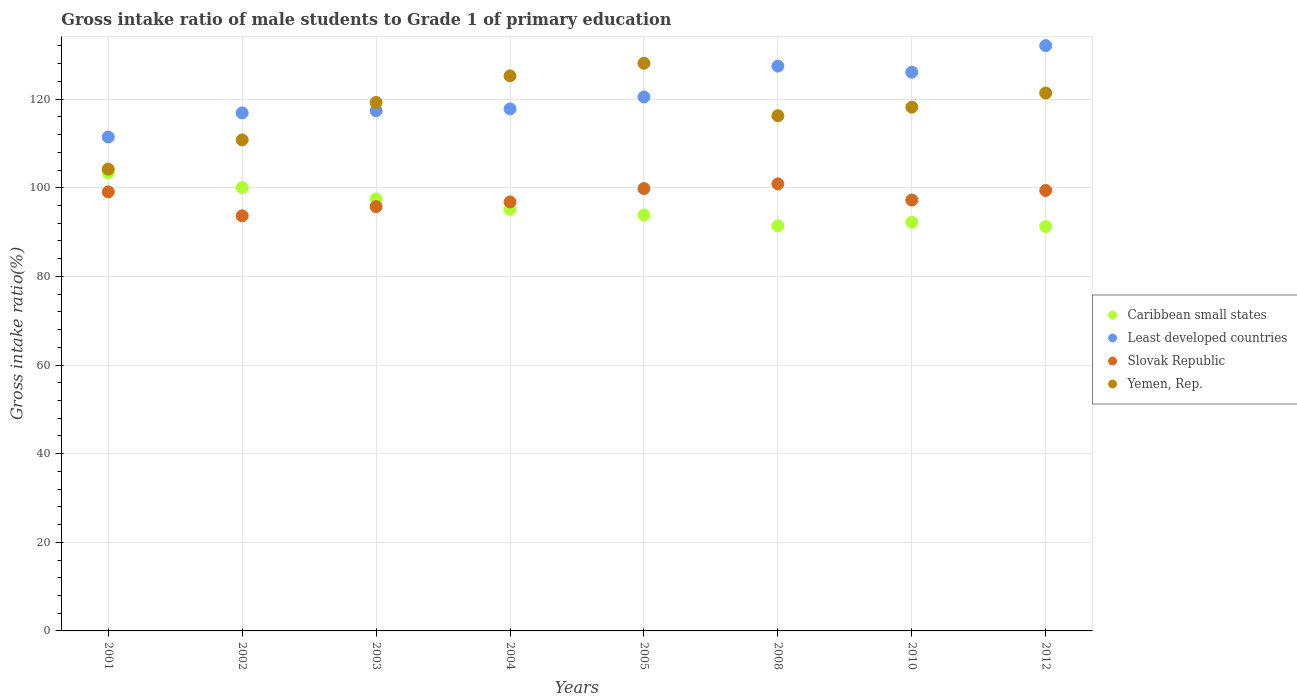What is the gross intake ratio in Caribbean small states in 2005?
Your answer should be very brief. 93.86. Across all years, what is the maximum gross intake ratio in Yemen, Rep.?
Make the answer very short. 128.1. Across all years, what is the minimum gross intake ratio in Yemen, Rep.?
Offer a terse response. 104.21. What is the total gross intake ratio in Least developed countries in the graph?
Your response must be concise. 969.67. What is the difference between the gross intake ratio in Least developed countries in 2001 and that in 2002?
Offer a terse response. -5.45. What is the difference between the gross intake ratio in Least developed countries in 2002 and the gross intake ratio in Caribbean small states in 2012?
Offer a terse response. 25.65. What is the average gross intake ratio in Least developed countries per year?
Offer a terse response. 121.21. In the year 2008, what is the difference between the gross intake ratio in Caribbean small states and gross intake ratio in Yemen, Rep.?
Keep it short and to the point. -24.82. In how many years, is the gross intake ratio in Least developed countries greater than 76 %?
Offer a very short reply. 8. What is the ratio of the gross intake ratio in Caribbean small states in 2002 to that in 2008?
Provide a short and direct response. 1.09. What is the difference between the highest and the second highest gross intake ratio in Yemen, Rep.?
Ensure brevity in your answer.  2.84. What is the difference between the highest and the lowest gross intake ratio in Slovak Republic?
Your response must be concise. 7.21. Is it the case that in every year, the sum of the gross intake ratio in Caribbean small states and gross intake ratio in Slovak Republic  is greater than the sum of gross intake ratio in Yemen, Rep. and gross intake ratio in Least developed countries?
Provide a short and direct response. No. Is it the case that in every year, the sum of the gross intake ratio in Least developed countries and gross intake ratio in Caribbean small states  is greater than the gross intake ratio in Yemen, Rep.?
Make the answer very short. Yes. Does the gross intake ratio in Caribbean small states monotonically increase over the years?
Your answer should be very brief. No. Are the values on the major ticks of Y-axis written in scientific E-notation?
Provide a succinct answer. No. Does the graph contain any zero values?
Provide a succinct answer. No. Where does the legend appear in the graph?
Offer a very short reply. Center right. How are the legend labels stacked?
Your answer should be very brief. Vertical. What is the title of the graph?
Offer a very short reply. Gross intake ratio of male students to Grade 1 of primary education. What is the label or title of the Y-axis?
Keep it short and to the point. Gross intake ratio(%). What is the Gross intake ratio(%) of Caribbean small states in 2001?
Keep it short and to the point. 103.36. What is the Gross intake ratio(%) of Least developed countries in 2001?
Provide a succinct answer. 111.45. What is the Gross intake ratio(%) in Slovak Republic in 2001?
Keep it short and to the point. 99.08. What is the Gross intake ratio(%) of Yemen, Rep. in 2001?
Provide a short and direct response. 104.21. What is the Gross intake ratio(%) in Caribbean small states in 2002?
Provide a short and direct response. 100.05. What is the Gross intake ratio(%) in Least developed countries in 2002?
Make the answer very short. 116.91. What is the Gross intake ratio(%) in Slovak Republic in 2002?
Your response must be concise. 93.67. What is the Gross intake ratio(%) of Yemen, Rep. in 2002?
Offer a terse response. 110.8. What is the Gross intake ratio(%) in Caribbean small states in 2003?
Provide a short and direct response. 97.49. What is the Gross intake ratio(%) of Least developed countries in 2003?
Provide a succinct answer. 117.39. What is the Gross intake ratio(%) of Slovak Republic in 2003?
Your answer should be compact. 95.75. What is the Gross intake ratio(%) in Yemen, Rep. in 2003?
Make the answer very short. 119.26. What is the Gross intake ratio(%) of Caribbean small states in 2004?
Ensure brevity in your answer.  95.14. What is the Gross intake ratio(%) in Least developed countries in 2004?
Your response must be concise. 117.81. What is the Gross intake ratio(%) in Slovak Republic in 2004?
Ensure brevity in your answer.  96.81. What is the Gross intake ratio(%) in Yemen, Rep. in 2004?
Give a very brief answer. 125.26. What is the Gross intake ratio(%) in Caribbean small states in 2005?
Offer a very short reply. 93.86. What is the Gross intake ratio(%) of Least developed countries in 2005?
Your answer should be compact. 120.49. What is the Gross intake ratio(%) of Slovak Republic in 2005?
Your answer should be very brief. 99.82. What is the Gross intake ratio(%) of Yemen, Rep. in 2005?
Make the answer very short. 128.1. What is the Gross intake ratio(%) in Caribbean small states in 2008?
Make the answer very short. 91.44. What is the Gross intake ratio(%) in Least developed countries in 2008?
Your answer should be very brief. 127.46. What is the Gross intake ratio(%) in Slovak Republic in 2008?
Keep it short and to the point. 100.88. What is the Gross intake ratio(%) of Yemen, Rep. in 2008?
Ensure brevity in your answer.  116.26. What is the Gross intake ratio(%) of Caribbean small states in 2010?
Keep it short and to the point. 92.23. What is the Gross intake ratio(%) in Least developed countries in 2010?
Provide a succinct answer. 126.09. What is the Gross intake ratio(%) of Slovak Republic in 2010?
Offer a very short reply. 97.24. What is the Gross intake ratio(%) in Yemen, Rep. in 2010?
Offer a very short reply. 118.19. What is the Gross intake ratio(%) of Caribbean small states in 2012?
Give a very brief answer. 91.25. What is the Gross intake ratio(%) of Least developed countries in 2012?
Make the answer very short. 132.08. What is the Gross intake ratio(%) of Slovak Republic in 2012?
Your answer should be very brief. 99.39. What is the Gross intake ratio(%) of Yemen, Rep. in 2012?
Your answer should be very brief. 121.39. Across all years, what is the maximum Gross intake ratio(%) in Caribbean small states?
Offer a terse response. 103.36. Across all years, what is the maximum Gross intake ratio(%) in Least developed countries?
Your response must be concise. 132.08. Across all years, what is the maximum Gross intake ratio(%) in Slovak Republic?
Your answer should be compact. 100.88. Across all years, what is the maximum Gross intake ratio(%) in Yemen, Rep.?
Keep it short and to the point. 128.1. Across all years, what is the minimum Gross intake ratio(%) of Caribbean small states?
Offer a very short reply. 91.25. Across all years, what is the minimum Gross intake ratio(%) in Least developed countries?
Provide a short and direct response. 111.45. Across all years, what is the minimum Gross intake ratio(%) of Slovak Republic?
Your answer should be very brief. 93.67. Across all years, what is the minimum Gross intake ratio(%) in Yemen, Rep.?
Offer a very short reply. 104.21. What is the total Gross intake ratio(%) in Caribbean small states in the graph?
Provide a short and direct response. 764.82. What is the total Gross intake ratio(%) of Least developed countries in the graph?
Your answer should be compact. 969.67. What is the total Gross intake ratio(%) of Slovak Republic in the graph?
Keep it short and to the point. 782.64. What is the total Gross intake ratio(%) of Yemen, Rep. in the graph?
Offer a terse response. 943.48. What is the difference between the Gross intake ratio(%) in Caribbean small states in 2001 and that in 2002?
Provide a short and direct response. 3.31. What is the difference between the Gross intake ratio(%) in Least developed countries in 2001 and that in 2002?
Your answer should be very brief. -5.45. What is the difference between the Gross intake ratio(%) in Slovak Republic in 2001 and that in 2002?
Offer a very short reply. 5.41. What is the difference between the Gross intake ratio(%) of Yemen, Rep. in 2001 and that in 2002?
Provide a succinct answer. -6.59. What is the difference between the Gross intake ratio(%) in Caribbean small states in 2001 and that in 2003?
Your answer should be compact. 5.87. What is the difference between the Gross intake ratio(%) of Least developed countries in 2001 and that in 2003?
Offer a very short reply. -5.93. What is the difference between the Gross intake ratio(%) of Slovak Republic in 2001 and that in 2003?
Make the answer very short. 3.32. What is the difference between the Gross intake ratio(%) of Yemen, Rep. in 2001 and that in 2003?
Your answer should be compact. -15.05. What is the difference between the Gross intake ratio(%) of Caribbean small states in 2001 and that in 2004?
Your answer should be compact. 8.22. What is the difference between the Gross intake ratio(%) in Least developed countries in 2001 and that in 2004?
Keep it short and to the point. -6.35. What is the difference between the Gross intake ratio(%) in Slovak Republic in 2001 and that in 2004?
Keep it short and to the point. 2.27. What is the difference between the Gross intake ratio(%) in Yemen, Rep. in 2001 and that in 2004?
Offer a terse response. -21.05. What is the difference between the Gross intake ratio(%) in Caribbean small states in 2001 and that in 2005?
Your response must be concise. 9.5. What is the difference between the Gross intake ratio(%) in Least developed countries in 2001 and that in 2005?
Offer a very short reply. -9.04. What is the difference between the Gross intake ratio(%) in Slovak Republic in 2001 and that in 2005?
Ensure brevity in your answer.  -0.75. What is the difference between the Gross intake ratio(%) of Yemen, Rep. in 2001 and that in 2005?
Ensure brevity in your answer.  -23.89. What is the difference between the Gross intake ratio(%) of Caribbean small states in 2001 and that in 2008?
Give a very brief answer. 11.92. What is the difference between the Gross intake ratio(%) in Least developed countries in 2001 and that in 2008?
Offer a very short reply. -16.01. What is the difference between the Gross intake ratio(%) in Slovak Republic in 2001 and that in 2008?
Your answer should be compact. -1.8. What is the difference between the Gross intake ratio(%) of Yemen, Rep. in 2001 and that in 2008?
Make the answer very short. -12.05. What is the difference between the Gross intake ratio(%) of Caribbean small states in 2001 and that in 2010?
Offer a terse response. 11.13. What is the difference between the Gross intake ratio(%) in Least developed countries in 2001 and that in 2010?
Ensure brevity in your answer.  -14.63. What is the difference between the Gross intake ratio(%) in Slovak Republic in 2001 and that in 2010?
Your answer should be compact. 1.84. What is the difference between the Gross intake ratio(%) in Yemen, Rep. in 2001 and that in 2010?
Your answer should be compact. -13.98. What is the difference between the Gross intake ratio(%) of Caribbean small states in 2001 and that in 2012?
Your answer should be compact. 12.11. What is the difference between the Gross intake ratio(%) of Least developed countries in 2001 and that in 2012?
Give a very brief answer. -20.63. What is the difference between the Gross intake ratio(%) of Slovak Republic in 2001 and that in 2012?
Your answer should be very brief. -0.32. What is the difference between the Gross intake ratio(%) in Yemen, Rep. in 2001 and that in 2012?
Make the answer very short. -17.18. What is the difference between the Gross intake ratio(%) in Caribbean small states in 2002 and that in 2003?
Provide a succinct answer. 2.56. What is the difference between the Gross intake ratio(%) in Least developed countries in 2002 and that in 2003?
Make the answer very short. -0.48. What is the difference between the Gross intake ratio(%) in Slovak Republic in 2002 and that in 2003?
Make the answer very short. -2.08. What is the difference between the Gross intake ratio(%) of Yemen, Rep. in 2002 and that in 2003?
Give a very brief answer. -8.46. What is the difference between the Gross intake ratio(%) in Caribbean small states in 2002 and that in 2004?
Provide a succinct answer. 4.91. What is the difference between the Gross intake ratio(%) of Least developed countries in 2002 and that in 2004?
Offer a terse response. -0.9. What is the difference between the Gross intake ratio(%) of Slovak Republic in 2002 and that in 2004?
Keep it short and to the point. -3.14. What is the difference between the Gross intake ratio(%) in Yemen, Rep. in 2002 and that in 2004?
Your response must be concise. -14.46. What is the difference between the Gross intake ratio(%) of Caribbean small states in 2002 and that in 2005?
Ensure brevity in your answer.  6.19. What is the difference between the Gross intake ratio(%) in Least developed countries in 2002 and that in 2005?
Offer a very short reply. -3.58. What is the difference between the Gross intake ratio(%) of Slovak Republic in 2002 and that in 2005?
Offer a very short reply. -6.15. What is the difference between the Gross intake ratio(%) in Yemen, Rep. in 2002 and that in 2005?
Provide a short and direct response. -17.3. What is the difference between the Gross intake ratio(%) in Caribbean small states in 2002 and that in 2008?
Your answer should be very brief. 8.61. What is the difference between the Gross intake ratio(%) of Least developed countries in 2002 and that in 2008?
Offer a very short reply. -10.55. What is the difference between the Gross intake ratio(%) in Slovak Republic in 2002 and that in 2008?
Offer a terse response. -7.21. What is the difference between the Gross intake ratio(%) in Yemen, Rep. in 2002 and that in 2008?
Offer a very short reply. -5.46. What is the difference between the Gross intake ratio(%) of Caribbean small states in 2002 and that in 2010?
Make the answer very short. 7.82. What is the difference between the Gross intake ratio(%) in Least developed countries in 2002 and that in 2010?
Your answer should be compact. -9.18. What is the difference between the Gross intake ratio(%) in Slovak Republic in 2002 and that in 2010?
Make the answer very short. -3.57. What is the difference between the Gross intake ratio(%) of Yemen, Rep. in 2002 and that in 2010?
Your response must be concise. -7.39. What is the difference between the Gross intake ratio(%) in Caribbean small states in 2002 and that in 2012?
Ensure brevity in your answer.  8.8. What is the difference between the Gross intake ratio(%) of Least developed countries in 2002 and that in 2012?
Your answer should be compact. -15.18. What is the difference between the Gross intake ratio(%) in Slovak Republic in 2002 and that in 2012?
Your response must be concise. -5.72. What is the difference between the Gross intake ratio(%) in Yemen, Rep. in 2002 and that in 2012?
Offer a terse response. -10.59. What is the difference between the Gross intake ratio(%) in Caribbean small states in 2003 and that in 2004?
Keep it short and to the point. 2.35. What is the difference between the Gross intake ratio(%) in Least developed countries in 2003 and that in 2004?
Your response must be concise. -0.42. What is the difference between the Gross intake ratio(%) in Slovak Republic in 2003 and that in 2004?
Offer a very short reply. -1.06. What is the difference between the Gross intake ratio(%) of Yemen, Rep. in 2003 and that in 2004?
Your answer should be very brief. -6. What is the difference between the Gross intake ratio(%) of Caribbean small states in 2003 and that in 2005?
Ensure brevity in your answer.  3.62. What is the difference between the Gross intake ratio(%) in Least developed countries in 2003 and that in 2005?
Offer a terse response. -3.1. What is the difference between the Gross intake ratio(%) of Slovak Republic in 2003 and that in 2005?
Provide a succinct answer. -4.07. What is the difference between the Gross intake ratio(%) of Yemen, Rep. in 2003 and that in 2005?
Make the answer very short. -8.84. What is the difference between the Gross intake ratio(%) in Caribbean small states in 2003 and that in 2008?
Give a very brief answer. 6.05. What is the difference between the Gross intake ratio(%) in Least developed countries in 2003 and that in 2008?
Keep it short and to the point. -10.07. What is the difference between the Gross intake ratio(%) of Slovak Republic in 2003 and that in 2008?
Offer a terse response. -5.13. What is the difference between the Gross intake ratio(%) of Yemen, Rep. in 2003 and that in 2008?
Provide a succinct answer. 3. What is the difference between the Gross intake ratio(%) of Caribbean small states in 2003 and that in 2010?
Your answer should be very brief. 5.26. What is the difference between the Gross intake ratio(%) of Least developed countries in 2003 and that in 2010?
Your response must be concise. -8.7. What is the difference between the Gross intake ratio(%) of Slovak Republic in 2003 and that in 2010?
Give a very brief answer. -1.48. What is the difference between the Gross intake ratio(%) of Yemen, Rep. in 2003 and that in 2010?
Provide a short and direct response. 1.06. What is the difference between the Gross intake ratio(%) in Caribbean small states in 2003 and that in 2012?
Provide a succinct answer. 6.24. What is the difference between the Gross intake ratio(%) of Least developed countries in 2003 and that in 2012?
Ensure brevity in your answer.  -14.7. What is the difference between the Gross intake ratio(%) of Slovak Republic in 2003 and that in 2012?
Offer a terse response. -3.64. What is the difference between the Gross intake ratio(%) of Yemen, Rep. in 2003 and that in 2012?
Ensure brevity in your answer.  -2.14. What is the difference between the Gross intake ratio(%) of Caribbean small states in 2004 and that in 2005?
Ensure brevity in your answer.  1.27. What is the difference between the Gross intake ratio(%) of Least developed countries in 2004 and that in 2005?
Your answer should be very brief. -2.68. What is the difference between the Gross intake ratio(%) of Slovak Republic in 2004 and that in 2005?
Offer a terse response. -3.01. What is the difference between the Gross intake ratio(%) in Yemen, Rep. in 2004 and that in 2005?
Provide a short and direct response. -2.84. What is the difference between the Gross intake ratio(%) of Caribbean small states in 2004 and that in 2008?
Your answer should be very brief. 3.7. What is the difference between the Gross intake ratio(%) of Least developed countries in 2004 and that in 2008?
Your answer should be very brief. -9.65. What is the difference between the Gross intake ratio(%) in Slovak Republic in 2004 and that in 2008?
Give a very brief answer. -4.07. What is the difference between the Gross intake ratio(%) in Yemen, Rep. in 2004 and that in 2008?
Your answer should be compact. 9. What is the difference between the Gross intake ratio(%) of Caribbean small states in 2004 and that in 2010?
Your response must be concise. 2.91. What is the difference between the Gross intake ratio(%) in Least developed countries in 2004 and that in 2010?
Offer a very short reply. -8.28. What is the difference between the Gross intake ratio(%) of Slovak Republic in 2004 and that in 2010?
Your answer should be very brief. -0.43. What is the difference between the Gross intake ratio(%) of Yemen, Rep. in 2004 and that in 2010?
Offer a terse response. 7.07. What is the difference between the Gross intake ratio(%) in Caribbean small states in 2004 and that in 2012?
Offer a very short reply. 3.89. What is the difference between the Gross intake ratio(%) in Least developed countries in 2004 and that in 2012?
Your answer should be compact. -14.28. What is the difference between the Gross intake ratio(%) in Slovak Republic in 2004 and that in 2012?
Make the answer very short. -2.58. What is the difference between the Gross intake ratio(%) of Yemen, Rep. in 2004 and that in 2012?
Your response must be concise. 3.87. What is the difference between the Gross intake ratio(%) in Caribbean small states in 2005 and that in 2008?
Provide a succinct answer. 2.43. What is the difference between the Gross intake ratio(%) in Least developed countries in 2005 and that in 2008?
Give a very brief answer. -6.97. What is the difference between the Gross intake ratio(%) in Slovak Republic in 2005 and that in 2008?
Your answer should be compact. -1.06. What is the difference between the Gross intake ratio(%) of Yemen, Rep. in 2005 and that in 2008?
Keep it short and to the point. 11.84. What is the difference between the Gross intake ratio(%) in Caribbean small states in 2005 and that in 2010?
Ensure brevity in your answer.  1.63. What is the difference between the Gross intake ratio(%) of Least developed countries in 2005 and that in 2010?
Give a very brief answer. -5.6. What is the difference between the Gross intake ratio(%) in Slovak Republic in 2005 and that in 2010?
Your response must be concise. 2.59. What is the difference between the Gross intake ratio(%) in Yemen, Rep. in 2005 and that in 2010?
Provide a succinct answer. 9.91. What is the difference between the Gross intake ratio(%) of Caribbean small states in 2005 and that in 2012?
Make the answer very short. 2.61. What is the difference between the Gross intake ratio(%) in Least developed countries in 2005 and that in 2012?
Keep it short and to the point. -11.6. What is the difference between the Gross intake ratio(%) in Slovak Republic in 2005 and that in 2012?
Make the answer very short. 0.43. What is the difference between the Gross intake ratio(%) of Yemen, Rep. in 2005 and that in 2012?
Provide a succinct answer. 6.71. What is the difference between the Gross intake ratio(%) in Caribbean small states in 2008 and that in 2010?
Offer a very short reply. -0.79. What is the difference between the Gross intake ratio(%) of Least developed countries in 2008 and that in 2010?
Offer a terse response. 1.37. What is the difference between the Gross intake ratio(%) in Slovak Republic in 2008 and that in 2010?
Provide a short and direct response. 3.64. What is the difference between the Gross intake ratio(%) of Yemen, Rep. in 2008 and that in 2010?
Keep it short and to the point. -1.93. What is the difference between the Gross intake ratio(%) of Caribbean small states in 2008 and that in 2012?
Offer a very short reply. 0.18. What is the difference between the Gross intake ratio(%) of Least developed countries in 2008 and that in 2012?
Your answer should be very brief. -4.62. What is the difference between the Gross intake ratio(%) in Slovak Republic in 2008 and that in 2012?
Keep it short and to the point. 1.49. What is the difference between the Gross intake ratio(%) of Yemen, Rep. in 2008 and that in 2012?
Provide a short and direct response. -5.13. What is the difference between the Gross intake ratio(%) in Caribbean small states in 2010 and that in 2012?
Your answer should be very brief. 0.98. What is the difference between the Gross intake ratio(%) in Least developed countries in 2010 and that in 2012?
Your response must be concise. -6. What is the difference between the Gross intake ratio(%) of Slovak Republic in 2010 and that in 2012?
Provide a succinct answer. -2.16. What is the difference between the Gross intake ratio(%) in Yemen, Rep. in 2010 and that in 2012?
Provide a succinct answer. -3.2. What is the difference between the Gross intake ratio(%) in Caribbean small states in 2001 and the Gross intake ratio(%) in Least developed countries in 2002?
Provide a succinct answer. -13.55. What is the difference between the Gross intake ratio(%) of Caribbean small states in 2001 and the Gross intake ratio(%) of Slovak Republic in 2002?
Make the answer very short. 9.69. What is the difference between the Gross intake ratio(%) in Caribbean small states in 2001 and the Gross intake ratio(%) in Yemen, Rep. in 2002?
Keep it short and to the point. -7.44. What is the difference between the Gross intake ratio(%) in Least developed countries in 2001 and the Gross intake ratio(%) in Slovak Republic in 2002?
Provide a succinct answer. 17.78. What is the difference between the Gross intake ratio(%) in Least developed countries in 2001 and the Gross intake ratio(%) in Yemen, Rep. in 2002?
Provide a short and direct response. 0.65. What is the difference between the Gross intake ratio(%) in Slovak Republic in 2001 and the Gross intake ratio(%) in Yemen, Rep. in 2002?
Your answer should be very brief. -11.73. What is the difference between the Gross intake ratio(%) of Caribbean small states in 2001 and the Gross intake ratio(%) of Least developed countries in 2003?
Your answer should be compact. -14.02. What is the difference between the Gross intake ratio(%) of Caribbean small states in 2001 and the Gross intake ratio(%) of Slovak Republic in 2003?
Keep it short and to the point. 7.61. What is the difference between the Gross intake ratio(%) in Caribbean small states in 2001 and the Gross intake ratio(%) in Yemen, Rep. in 2003?
Your answer should be compact. -15.9. What is the difference between the Gross intake ratio(%) in Least developed countries in 2001 and the Gross intake ratio(%) in Slovak Republic in 2003?
Give a very brief answer. 15.7. What is the difference between the Gross intake ratio(%) of Least developed countries in 2001 and the Gross intake ratio(%) of Yemen, Rep. in 2003?
Your response must be concise. -7.81. What is the difference between the Gross intake ratio(%) in Slovak Republic in 2001 and the Gross intake ratio(%) in Yemen, Rep. in 2003?
Keep it short and to the point. -20.18. What is the difference between the Gross intake ratio(%) of Caribbean small states in 2001 and the Gross intake ratio(%) of Least developed countries in 2004?
Your response must be concise. -14.45. What is the difference between the Gross intake ratio(%) in Caribbean small states in 2001 and the Gross intake ratio(%) in Slovak Republic in 2004?
Provide a succinct answer. 6.55. What is the difference between the Gross intake ratio(%) of Caribbean small states in 2001 and the Gross intake ratio(%) of Yemen, Rep. in 2004?
Your answer should be compact. -21.9. What is the difference between the Gross intake ratio(%) of Least developed countries in 2001 and the Gross intake ratio(%) of Slovak Republic in 2004?
Provide a short and direct response. 14.64. What is the difference between the Gross intake ratio(%) of Least developed countries in 2001 and the Gross intake ratio(%) of Yemen, Rep. in 2004?
Give a very brief answer. -13.81. What is the difference between the Gross intake ratio(%) in Slovak Republic in 2001 and the Gross intake ratio(%) in Yemen, Rep. in 2004?
Offer a very short reply. -26.18. What is the difference between the Gross intake ratio(%) of Caribbean small states in 2001 and the Gross intake ratio(%) of Least developed countries in 2005?
Your answer should be compact. -17.13. What is the difference between the Gross intake ratio(%) of Caribbean small states in 2001 and the Gross intake ratio(%) of Slovak Republic in 2005?
Give a very brief answer. 3.54. What is the difference between the Gross intake ratio(%) in Caribbean small states in 2001 and the Gross intake ratio(%) in Yemen, Rep. in 2005?
Ensure brevity in your answer.  -24.74. What is the difference between the Gross intake ratio(%) of Least developed countries in 2001 and the Gross intake ratio(%) of Slovak Republic in 2005?
Keep it short and to the point. 11.63. What is the difference between the Gross intake ratio(%) of Least developed countries in 2001 and the Gross intake ratio(%) of Yemen, Rep. in 2005?
Your response must be concise. -16.65. What is the difference between the Gross intake ratio(%) in Slovak Republic in 2001 and the Gross intake ratio(%) in Yemen, Rep. in 2005?
Offer a very short reply. -29.02. What is the difference between the Gross intake ratio(%) in Caribbean small states in 2001 and the Gross intake ratio(%) in Least developed countries in 2008?
Give a very brief answer. -24.1. What is the difference between the Gross intake ratio(%) in Caribbean small states in 2001 and the Gross intake ratio(%) in Slovak Republic in 2008?
Keep it short and to the point. 2.48. What is the difference between the Gross intake ratio(%) of Caribbean small states in 2001 and the Gross intake ratio(%) of Yemen, Rep. in 2008?
Provide a short and direct response. -12.9. What is the difference between the Gross intake ratio(%) in Least developed countries in 2001 and the Gross intake ratio(%) in Slovak Republic in 2008?
Keep it short and to the point. 10.57. What is the difference between the Gross intake ratio(%) of Least developed countries in 2001 and the Gross intake ratio(%) of Yemen, Rep. in 2008?
Offer a terse response. -4.81. What is the difference between the Gross intake ratio(%) in Slovak Republic in 2001 and the Gross intake ratio(%) in Yemen, Rep. in 2008?
Provide a short and direct response. -17.18. What is the difference between the Gross intake ratio(%) in Caribbean small states in 2001 and the Gross intake ratio(%) in Least developed countries in 2010?
Give a very brief answer. -22.72. What is the difference between the Gross intake ratio(%) in Caribbean small states in 2001 and the Gross intake ratio(%) in Slovak Republic in 2010?
Make the answer very short. 6.12. What is the difference between the Gross intake ratio(%) in Caribbean small states in 2001 and the Gross intake ratio(%) in Yemen, Rep. in 2010?
Offer a very short reply. -14.83. What is the difference between the Gross intake ratio(%) in Least developed countries in 2001 and the Gross intake ratio(%) in Slovak Republic in 2010?
Your answer should be very brief. 14.22. What is the difference between the Gross intake ratio(%) of Least developed countries in 2001 and the Gross intake ratio(%) of Yemen, Rep. in 2010?
Provide a succinct answer. -6.74. What is the difference between the Gross intake ratio(%) of Slovak Republic in 2001 and the Gross intake ratio(%) of Yemen, Rep. in 2010?
Keep it short and to the point. -19.12. What is the difference between the Gross intake ratio(%) in Caribbean small states in 2001 and the Gross intake ratio(%) in Least developed countries in 2012?
Your response must be concise. -28.72. What is the difference between the Gross intake ratio(%) in Caribbean small states in 2001 and the Gross intake ratio(%) in Slovak Republic in 2012?
Provide a short and direct response. 3.97. What is the difference between the Gross intake ratio(%) in Caribbean small states in 2001 and the Gross intake ratio(%) in Yemen, Rep. in 2012?
Provide a succinct answer. -18.03. What is the difference between the Gross intake ratio(%) of Least developed countries in 2001 and the Gross intake ratio(%) of Slovak Republic in 2012?
Ensure brevity in your answer.  12.06. What is the difference between the Gross intake ratio(%) of Least developed countries in 2001 and the Gross intake ratio(%) of Yemen, Rep. in 2012?
Provide a succinct answer. -9.94. What is the difference between the Gross intake ratio(%) of Slovak Republic in 2001 and the Gross intake ratio(%) of Yemen, Rep. in 2012?
Offer a terse response. -22.32. What is the difference between the Gross intake ratio(%) of Caribbean small states in 2002 and the Gross intake ratio(%) of Least developed countries in 2003?
Your response must be concise. -17.34. What is the difference between the Gross intake ratio(%) of Caribbean small states in 2002 and the Gross intake ratio(%) of Slovak Republic in 2003?
Your answer should be compact. 4.3. What is the difference between the Gross intake ratio(%) of Caribbean small states in 2002 and the Gross intake ratio(%) of Yemen, Rep. in 2003?
Keep it short and to the point. -19.21. What is the difference between the Gross intake ratio(%) in Least developed countries in 2002 and the Gross intake ratio(%) in Slovak Republic in 2003?
Provide a succinct answer. 21.15. What is the difference between the Gross intake ratio(%) of Least developed countries in 2002 and the Gross intake ratio(%) of Yemen, Rep. in 2003?
Keep it short and to the point. -2.35. What is the difference between the Gross intake ratio(%) in Slovak Republic in 2002 and the Gross intake ratio(%) in Yemen, Rep. in 2003?
Offer a terse response. -25.59. What is the difference between the Gross intake ratio(%) in Caribbean small states in 2002 and the Gross intake ratio(%) in Least developed countries in 2004?
Your response must be concise. -17.76. What is the difference between the Gross intake ratio(%) in Caribbean small states in 2002 and the Gross intake ratio(%) in Slovak Republic in 2004?
Provide a succinct answer. 3.24. What is the difference between the Gross intake ratio(%) in Caribbean small states in 2002 and the Gross intake ratio(%) in Yemen, Rep. in 2004?
Offer a terse response. -25.21. What is the difference between the Gross intake ratio(%) of Least developed countries in 2002 and the Gross intake ratio(%) of Slovak Republic in 2004?
Keep it short and to the point. 20.1. What is the difference between the Gross intake ratio(%) in Least developed countries in 2002 and the Gross intake ratio(%) in Yemen, Rep. in 2004?
Offer a terse response. -8.35. What is the difference between the Gross intake ratio(%) in Slovak Republic in 2002 and the Gross intake ratio(%) in Yemen, Rep. in 2004?
Keep it short and to the point. -31.59. What is the difference between the Gross intake ratio(%) of Caribbean small states in 2002 and the Gross intake ratio(%) of Least developed countries in 2005?
Offer a terse response. -20.44. What is the difference between the Gross intake ratio(%) of Caribbean small states in 2002 and the Gross intake ratio(%) of Slovak Republic in 2005?
Give a very brief answer. 0.23. What is the difference between the Gross intake ratio(%) of Caribbean small states in 2002 and the Gross intake ratio(%) of Yemen, Rep. in 2005?
Your answer should be very brief. -28.05. What is the difference between the Gross intake ratio(%) in Least developed countries in 2002 and the Gross intake ratio(%) in Slovak Republic in 2005?
Provide a short and direct response. 17.08. What is the difference between the Gross intake ratio(%) in Least developed countries in 2002 and the Gross intake ratio(%) in Yemen, Rep. in 2005?
Provide a succinct answer. -11.19. What is the difference between the Gross intake ratio(%) of Slovak Republic in 2002 and the Gross intake ratio(%) of Yemen, Rep. in 2005?
Provide a succinct answer. -34.43. What is the difference between the Gross intake ratio(%) of Caribbean small states in 2002 and the Gross intake ratio(%) of Least developed countries in 2008?
Keep it short and to the point. -27.41. What is the difference between the Gross intake ratio(%) of Caribbean small states in 2002 and the Gross intake ratio(%) of Slovak Republic in 2008?
Give a very brief answer. -0.83. What is the difference between the Gross intake ratio(%) in Caribbean small states in 2002 and the Gross intake ratio(%) in Yemen, Rep. in 2008?
Ensure brevity in your answer.  -16.21. What is the difference between the Gross intake ratio(%) in Least developed countries in 2002 and the Gross intake ratio(%) in Slovak Republic in 2008?
Ensure brevity in your answer.  16.03. What is the difference between the Gross intake ratio(%) of Least developed countries in 2002 and the Gross intake ratio(%) of Yemen, Rep. in 2008?
Your answer should be compact. 0.65. What is the difference between the Gross intake ratio(%) of Slovak Republic in 2002 and the Gross intake ratio(%) of Yemen, Rep. in 2008?
Give a very brief answer. -22.59. What is the difference between the Gross intake ratio(%) in Caribbean small states in 2002 and the Gross intake ratio(%) in Least developed countries in 2010?
Give a very brief answer. -26.04. What is the difference between the Gross intake ratio(%) of Caribbean small states in 2002 and the Gross intake ratio(%) of Slovak Republic in 2010?
Offer a very short reply. 2.81. What is the difference between the Gross intake ratio(%) in Caribbean small states in 2002 and the Gross intake ratio(%) in Yemen, Rep. in 2010?
Offer a terse response. -18.14. What is the difference between the Gross intake ratio(%) in Least developed countries in 2002 and the Gross intake ratio(%) in Slovak Republic in 2010?
Your response must be concise. 19.67. What is the difference between the Gross intake ratio(%) in Least developed countries in 2002 and the Gross intake ratio(%) in Yemen, Rep. in 2010?
Keep it short and to the point. -1.29. What is the difference between the Gross intake ratio(%) of Slovak Republic in 2002 and the Gross intake ratio(%) of Yemen, Rep. in 2010?
Give a very brief answer. -24.52. What is the difference between the Gross intake ratio(%) of Caribbean small states in 2002 and the Gross intake ratio(%) of Least developed countries in 2012?
Your response must be concise. -32.03. What is the difference between the Gross intake ratio(%) in Caribbean small states in 2002 and the Gross intake ratio(%) in Slovak Republic in 2012?
Your response must be concise. 0.66. What is the difference between the Gross intake ratio(%) in Caribbean small states in 2002 and the Gross intake ratio(%) in Yemen, Rep. in 2012?
Your answer should be compact. -21.34. What is the difference between the Gross intake ratio(%) of Least developed countries in 2002 and the Gross intake ratio(%) of Slovak Republic in 2012?
Provide a succinct answer. 17.51. What is the difference between the Gross intake ratio(%) in Least developed countries in 2002 and the Gross intake ratio(%) in Yemen, Rep. in 2012?
Provide a short and direct response. -4.49. What is the difference between the Gross intake ratio(%) of Slovak Republic in 2002 and the Gross intake ratio(%) of Yemen, Rep. in 2012?
Offer a terse response. -27.72. What is the difference between the Gross intake ratio(%) in Caribbean small states in 2003 and the Gross intake ratio(%) in Least developed countries in 2004?
Your answer should be very brief. -20.32. What is the difference between the Gross intake ratio(%) of Caribbean small states in 2003 and the Gross intake ratio(%) of Slovak Republic in 2004?
Keep it short and to the point. 0.68. What is the difference between the Gross intake ratio(%) of Caribbean small states in 2003 and the Gross intake ratio(%) of Yemen, Rep. in 2004?
Your response must be concise. -27.77. What is the difference between the Gross intake ratio(%) in Least developed countries in 2003 and the Gross intake ratio(%) in Slovak Republic in 2004?
Offer a very short reply. 20.57. What is the difference between the Gross intake ratio(%) in Least developed countries in 2003 and the Gross intake ratio(%) in Yemen, Rep. in 2004?
Make the answer very short. -7.88. What is the difference between the Gross intake ratio(%) in Slovak Republic in 2003 and the Gross intake ratio(%) in Yemen, Rep. in 2004?
Offer a terse response. -29.51. What is the difference between the Gross intake ratio(%) in Caribbean small states in 2003 and the Gross intake ratio(%) in Least developed countries in 2005?
Offer a very short reply. -23. What is the difference between the Gross intake ratio(%) in Caribbean small states in 2003 and the Gross intake ratio(%) in Slovak Republic in 2005?
Give a very brief answer. -2.34. What is the difference between the Gross intake ratio(%) in Caribbean small states in 2003 and the Gross intake ratio(%) in Yemen, Rep. in 2005?
Keep it short and to the point. -30.61. What is the difference between the Gross intake ratio(%) of Least developed countries in 2003 and the Gross intake ratio(%) of Slovak Republic in 2005?
Ensure brevity in your answer.  17.56. What is the difference between the Gross intake ratio(%) in Least developed countries in 2003 and the Gross intake ratio(%) in Yemen, Rep. in 2005?
Keep it short and to the point. -10.71. What is the difference between the Gross intake ratio(%) of Slovak Republic in 2003 and the Gross intake ratio(%) of Yemen, Rep. in 2005?
Ensure brevity in your answer.  -32.35. What is the difference between the Gross intake ratio(%) in Caribbean small states in 2003 and the Gross intake ratio(%) in Least developed countries in 2008?
Offer a terse response. -29.97. What is the difference between the Gross intake ratio(%) of Caribbean small states in 2003 and the Gross intake ratio(%) of Slovak Republic in 2008?
Make the answer very short. -3.39. What is the difference between the Gross intake ratio(%) of Caribbean small states in 2003 and the Gross intake ratio(%) of Yemen, Rep. in 2008?
Offer a very short reply. -18.77. What is the difference between the Gross intake ratio(%) in Least developed countries in 2003 and the Gross intake ratio(%) in Slovak Republic in 2008?
Your answer should be compact. 16.51. What is the difference between the Gross intake ratio(%) in Least developed countries in 2003 and the Gross intake ratio(%) in Yemen, Rep. in 2008?
Offer a very short reply. 1.12. What is the difference between the Gross intake ratio(%) of Slovak Republic in 2003 and the Gross intake ratio(%) of Yemen, Rep. in 2008?
Your answer should be very brief. -20.51. What is the difference between the Gross intake ratio(%) in Caribbean small states in 2003 and the Gross intake ratio(%) in Least developed countries in 2010?
Offer a terse response. -28.6. What is the difference between the Gross intake ratio(%) of Caribbean small states in 2003 and the Gross intake ratio(%) of Slovak Republic in 2010?
Your answer should be compact. 0.25. What is the difference between the Gross intake ratio(%) in Caribbean small states in 2003 and the Gross intake ratio(%) in Yemen, Rep. in 2010?
Offer a very short reply. -20.71. What is the difference between the Gross intake ratio(%) in Least developed countries in 2003 and the Gross intake ratio(%) in Slovak Republic in 2010?
Keep it short and to the point. 20.15. What is the difference between the Gross intake ratio(%) in Least developed countries in 2003 and the Gross intake ratio(%) in Yemen, Rep. in 2010?
Your response must be concise. -0.81. What is the difference between the Gross intake ratio(%) in Slovak Republic in 2003 and the Gross intake ratio(%) in Yemen, Rep. in 2010?
Offer a terse response. -22.44. What is the difference between the Gross intake ratio(%) in Caribbean small states in 2003 and the Gross intake ratio(%) in Least developed countries in 2012?
Keep it short and to the point. -34.6. What is the difference between the Gross intake ratio(%) of Caribbean small states in 2003 and the Gross intake ratio(%) of Slovak Republic in 2012?
Keep it short and to the point. -1.91. What is the difference between the Gross intake ratio(%) in Caribbean small states in 2003 and the Gross intake ratio(%) in Yemen, Rep. in 2012?
Make the answer very short. -23.91. What is the difference between the Gross intake ratio(%) in Least developed countries in 2003 and the Gross intake ratio(%) in Slovak Republic in 2012?
Keep it short and to the point. 17.99. What is the difference between the Gross intake ratio(%) of Least developed countries in 2003 and the Gross intake ratio(%) of Yemen, Rep. in 2012?
Your answer should be compact. -4.01. What is the difference between the Gross intake ratio(%) of Slovak Republic in 2003 and the Gross intake ratio(%) of Yemen, Rep. in 2012?
Your response must be concise. -25.64. What is the difference between the Gross intake ratio(%) in Caribbean small states in 2004 and the Gross intake ratio(%) in Least developed countries in 2005?
Your answer should be very brief. -25.35. What is the difference between the Gross intake ratio(%) in Caribbean small states in 2004 and the Gross intake ratio(%) in Slovak Republic in 2005?
Your response must be concise. -4.69. What is the difference between the Gross intake ratio(%) in Caribbean small states in 2004 and the Gross intake ratio(%) in Yemen, Rep. in 2005?
Your answer should be very brief. -32.96. What is the difference between the Gross intake ratio(%) in Least developed countries in 2004 and the Gross intake ratio(%) in Slovak Republic in 2005?
Ensure brevity in your answer.  17.99. What is the difference between the Gross intake ratio(%) in Least developed countries in 2004 and the Gross intake ratio(%) in Yemen, Rep. in 2005?
Make the answer very short. -10.29. What is the difference between the Gross intake ratio(%) in Slovak Republic in 2004 and the Gross intake ratio(%) in Yemen, Rep. in 2005?
Provide a succinct answer. -31.29. What is the difference between the Gross intake ratio(%) in Caribbean small states in 2004 and the Gross intake ratio(%) in Least developed countries in 2008?
Your response must be concise. -32.32. What is the difference between the Gross intake ratio(%) of Caribbean small states in 2004 and the Gross intake ratio(%) of Slovak Republic in 2008?
Keep it short and to the point. -5.74. What is the difference between the Gross intake ratio(%) in Caribbean small states in 2004 and the Gross intake ratio(%) in Yemen, Rep. in 2008?
Offer a terse response. -21.12. What is the difference between the Gross intake ratio(%) of Least developed countries in 2004 and the Gross intake ratio(%) of Slovak Republic in 2008?
Offer a very short reply. 16.93. What is the difference between the Gross intake ratio(%) of Least developed countries in 2004 and the Gross intake ratio(%) of Yemen, Rep. in 2008?
Your answer should be very brief. 1.55. What is the difference between the Gross intake ratio(%) of Slovak Republic in 2004 and the Gross intake ratio(%) of Yemen, Rep. in 2008?
Your answer should be compact. -19.45. What is the difference between the Gross intake ratio(%) of Caribbean small states in 2004 and the Gross intake ratio(%) of Least developed countries in 2010?
Your response must be concise. -30.95. What is the difference between the Gross intake ratio(%) in Caribbean small states in 2004 and the Gross intake ratio(%) in Slovak Republic in 2010?
Offer a very short reply. -2.1. What is the difference between the Gross intake ratio(%) in Caribbean small states in 2004 and the Gross intake ratio(%) in Yemen, Rep. in 2010?
Your answer should be very brief. -23.06. What is the difference between the Gross intake ratio(%) in Least developed countries in 2004 and the Gross intake ratio(%) in Slovak Republic in 2010?
Offer a very short reply. 20.57. What is the difference between the Gross intake ratio(%) of Least developed countries in 2004 and the Gross intake ratio(%) of Yemen, Rep. in 2010?
Make the answer very short. -0.39. What is the difference between the Gross intake ratio(%) of Slovak Republic in 2004 and the Gross intake ratio(%) of Yemen, Rep. in 2010?
Offer a terse response. -21.38. What is the difference between the Gross intake ratio(%) in Caribbean small states in 2004 and the Gross intake ratio(%) in Least developed countries in 2012?
Your answer should be very brief. -36.95. What is the difference between the Gross intake ratio(%) in Caribbean small states in 2004 and the Gross intake ratio(%) in Slovak Republic in 2012?
Offer a terse response. -4.26. What is the difference between the Gross intake ratio(%) of Caribbean small states in 2004 and the Gross intake ratio(%) of Yemen, Rep. in 2012?
Give a very brief answer. -26.26. What is the difference between the Gross intake ratio(%) in Least developed countries in 2004 and the Gross intake ratio(%) in Slovak Republic in 2012?
Your answer should be compact. 18.42. What is the difference between the Gross intake ratio(%) of Least developed countries in 2004 and the Gross intake ratio(%) of Yemen, Rep. in 2012?
Offer a terse response. -3.59. What is the difference between the Gross intake ratio(%) in Slovak Republic in 2004 and the Gross intake ratio(%) in Yemen, Rep. in 2012?
Provide a short and direct response. -24.58. What is the difference between the Gross intake ratio(%) of Caribbean small states in 2005 and the Gross intake ratio(%) of Least developed countries in 2008?
Your response must be concise. -33.6. What is the difference between the Gross intake ratio(%) in Caribbean small states in 2005 and the Gross intake ratio(%) in Slovak Republic in 2008?
Offer a very short reply. -7.02. What is the difference between the Gross intake ratio(%) of Caribbean small states in 2005 and the Gross intake ratio(%) of Yemen, Rep. in 2008?
Provide a short and direct response. -22.4. What is the difference between the Gross intake ratio(%) of Least developed countries in 2005 and the Gross intake ratio(%) of Slovak Republic in 2008?
Your answer should be compact. 19.61. What is the difference between the Gross intake ratio(%) in Least developed countries in 2005 and the Gross intake ratio(%) in Yemen, Rep. in 2008?
Provide a succinct answer. 4.23. What is the difference between the Gross intake ratio(%) in Slovak Republic in 2005 and the Gross intake ratio(%) in Yemen, Rep. in 2008?
Offer a very short reply. -16.44. What is the difference between the Gross intake ratio(%) of Caribbean small states in 2005 and the Gross intake ratio(%) of Least developed countries in 2010?
Offer a very short reply. -32.22. What is the difference between the Gross intake ratio(%) in Caribbean small states in 2005 and the Gross intake ratio(%) in Slovak Republic in 2010?
Keep it short and to the point. -3.37. What is the difference between the Gross intake ratio(%) of Caribbean small states in 2005 and the Gross intake ratio(%) of Yemen, Rep. in 2010?
Provide a short and direct response. -24.33. What is the difference between the Gross intake ratio(%) in Least developed countries in 2005 and the Gross intake ratio(%) in Slovak Republic in 2010?
Your answer should be very brief. 23.25. What is the difference between the Gross intake ratio(%) in Least developed countries in 2005 and the Gross intake ratio(%) in Yemen, Rep. in 2010?
Keep it short and to the point. 2.29. What is the difference between the Gross intake ratio(%) in Slovak Republic in 2005 and the Gross intake ratio(%) in Yemen, Rep. in 2010?
Ensure brevity in your answer.  -18.37. What is the difference between the Gross intake ratio(%) of Caribbean small states in 2005 and the Gross intake ratio(%) of Least developed countries in 2012?
Offer a very short reply. -38.22. What is the difference between the Gross intake ratio(%) of Caribbean small states in 2005 and the Gross intake ratio(%) of Slovak Republic in 2012?
Keep it short and to the point. -5.53. What is the difference between the Gross intake ratio(%) in Caribbean small states in 2005 and the Gross intake ratio(%) in Yemen, Rep. in 2012?
Keep it short and to the point. -27.53. What is the difference between the Gross intake ratio(%) of Least developed countries in 2005 and the Gross intake ratio(%) of Slovak Republic in 2012?
Give a very brief answer. 21.1. What is the difference between the Gross intake ratio(%) in Least developed countries in 2005 and the Gross intake ratio(%) in Yemen, Rep. in 2012?
Your answer should be very brief. -0.91. What is the difference between the Gross intake ratio(%) of Slovak Republic in 2005 and the Gross intake ratio(%) of Yemen, Rep. in 2012?
Your answer should be compact. -21.57. What is the difference between the Gross intake ratio(%) of Caribbean small states in 2008 and the Gross intake ratio(%) of Least developed countries in 2010?
Ensure brevity in your answer.  -34.65. What is the difference between the Gross intake ratio(%) of Caribbean small states in 2008 and the Gross intake ratio(%) of Slovak Republic in 2010?
Offer a terse response. -5.8. What is the difference between the Gross intake ratio(%) in Caribbean small states in 2008 and the Gross intake ratio(%) in Yemen, Rep. in 2010?
Provide a succinct answer. -26.76. What is the difference between the Gross intake ratio(%) of Least developed countries in 2008 and the Gross intake ratio(%) of Slovak Republic in 2010?
Your response must be concise. 30.22. What is the difference between the Gross intake ratio(%) in Least developed countries in 2008 and the Gross intake ratio(%) in Yemen, Rep. in 2010?
Your response must be concise. 9.27. What is the difference between the Gross intake ratio(%) of Slovak Republic in 2008 and the Gross intake ratio(%) of Yemen, Rep. in 2010?
Ensure brevity in your answer.  -17.31. What is the difference between the Gross intake ratio(%) of Caribbean small states in 2008 and the Gross intake ratio(%) of Least developed countries in 2012?
Make the answer very short. -40.65. What is the difference between the Gross intake ratio(%) of Caribbean small states in 2008 and the Gross intake ratio(%) of Slovak Republic in 2012?
Your response must be concise. -7.96. What is the difference between the Gross intake ratio(%) in Caribbean small states in 2008 and the Gross intake ratio(%) in Yemen, Rep. in 2012?
Keep it short and to the point. -29.96. What is the difference between the Gross intake ratio(%) of Least developed countries in 2008 and the Gross intake ratio(%) of Slovak Republic in 2012?
Offer a very short reply. 28.07. What is the difference between the Gross intake ratio(%) in Least developed countries in 2008 and the Gross intake ratio(%) in Yemen, Rep. in 2012?
Offer a very short reply. 6.07. What is the difference between the Gross intake ratio(%) of Slovak Republic in 2008 and the Gross intake ratio(%) of Yemen, Rep. in 2012?
Your response must be concise. -20.51. What is the difference between the Gross intake ratio(%) in Caribbean small states in 2010 and the Gross intake ratio(%) in Least developed countries in 2012?
Offer a terse response. -39.85. What is the difference between the Gross intake ratio(%) of Caribbean small states in 2010 and the Gross intake ratio(%) of Slovak Republic in 2012?
Provide a short and direct response. -7.16. What is the difference between the Gross intake ratio(%) in Caribbean small states in 2010 and the Gross intake ratio(%) in Yemen, Rep. in 2012?
Keep it short and to the point. -29.16. What is the difference between the Gross intake ratio(%) in Least developed countries in 2010 and the Gross intake ratio(%) in Slovak Republic in 2012?
Make the answer very short. 26.69. What is the difference between the Gross intake ratio(%) in Least developed countries in 2010 and the Gross intake ratio(%) in Yemen, Rep. in 2012?
Provide a short and direct response. 4.69. What is the difference between the Gross intake ratio(%) of Slovak Republic in 2010 and the Gross intake ratio(%) of Yemen, Rep. in 2012?
Your answer should be very brief. -24.16. What is the average Gross intake ratio(%) in Caribbean small states per year?
Make the answer very short. 95.6. What is the average Gross intake ratio(%) in Least developed countries per year?
Your answer should be very brief. 121.21. What is the average Gross intake ratio(%) of Slovak Republic per year?
Offer a very short reply. 97.83. What is the average Gross intake ratio(%) in Yemen, Rep. per year?
Give a very brief answer. 117.93. In the year 2001, what is the difference between the Gross intake ratio(%) of Caribbean small states and Gross intake ratio(%) of Least developed countries?
Your answer should be compact. -8.09. In the year 2001, what is the difference between the Gross intake ratio(%) of Caribbean small states and Gross intake ratio(%) of Slovak Republic?
Give a very brief answer. 4.28. In the year 2001, what is the difference between the Gross intake ratio(%) in Caribbean small states and Gross intake ratio(%) in Yemen, Rep.?
Make the answer very short. -0.85. In the year 2001, what is the difference between the Gross intake ratio(%) in Least developed countries and Gross intake ratio(%) in Slovak Republic?
Offer a terse response. 12.38. In the year 2001, what is the difference between the Gross intake ratio(%) in Least developed countries and Gross intake ratio(%) in Yemen, Rep.?
Provide a succinct answer. 7.24. In the year 2001, what is the difference between the Gross intake ratio(%) of Slovak Republic and Gross intake ratio(%) of Yemen, Rep.?
Provide a short and direct response. -5.13. In the year 2002, what is the difference between the Gross intake ratio(%) of Caribbean small states and Gross intake ratio(%) of Least developed countries?
Offer a terse response. -16.86. In the year 2002, what is the difference between the Gross intake ratio(%) of Caribbean small states and Gross intake ratio(%) of Slovak Republic?
Your response must be concise. 6.38. In the year 2002, what is the difference between the Gross intake ratio(%) in Caribbean small states and Gross intake ratio(%) in Yemen, Rep.?
Your answer should be very brief. -10.75. In the year 2002, what is the difference between the Gross intake ratio(%) of Least developed countries and Gross intake ratio(%) of Slovak Republic?
Offer a terse response. 23.24. In the year 2002, what is the difference between the Gross intake ratio(%) of Least developed countries and Gross intake ratio(%) of Yemen, Rep.?
Your answer should be very brief. 6.1. In the year 2002, what is the difference between the Gross intake ratio(%) of Slovak Republic and Gross intake ratio(%) of Yemen, Rep.?
Offer a terse response. -17.13. In the year 2003, what is the difference between the Gross intake ratio(%) of Caribbean small states and Gross intake ratio(%) of Least developed countries?
Ensure brevity in your answer.  -19.9. In the year 2003, what is the difference between the Gross intake ratio(%) of Caribbean small states and Gross intake ratio(%) of Slovak Republic?
Offer a terse response. 1.73. In the year 2003, what is the difference between the Gross intake ratio(%) in Caribbean small states and Gross intake ratio(%) in Yemen, Rep.?
Provide a short and direct response. -21.77. In the year 2003, what is the difference between the Gross intake ratio(%) of Least developed countries and Gross intake ratio(%) of Slovak Republic?
Ensure brevity in your answer.  21.63. In the year 2003, what is the difference between the Gross intake ratio(%) in Least developed countries and Gross intake ratio(%) in Yemen, Rep.?
Ensure brevity in your answer.  -1.87. In the year 2003, what is the difference between the Gross intake ratio(%) of Slovak Republic and Gross intake ratio(%) of Yemen, Rep.?
Your answer should be compact. -23.5. In the year 2004, what is the difference between the Gross intake ratio(%) of Caribbean small states and Gross intake ratio(%) of Least developed countries?
Your answer should be very brief. -22.67. In the year 2004, what is the difference between the Gross intake ratio(%) in Caribbean small states and Gross intake ratio(%) in Slovak Republic?
Provide a succinct answer. -1.67. In the year 2004, what is the difference between the Gross intake ratio(%) in Caribbean small states and Gross intake ratio(%) in Yemen, Rep.?
Give a very brief answer. -30.12. In the year 2004, what is the difference between the Gross intake ratio(%) in Least developed countries and Gross intake ratio(%) in Slovak Republic?
Make the answer very short. 21. In the year 2004, what is the difference between the Gross intake ratio(%) in Least developed countries and Gross intake ratio(%) in Yemen, Rep.?
Provide a succinct answer. -7.45. In the year 2004, what is the difference between the Gross intake ratio(%) of Slovak Republic and Gross intake ratio(%) of Yemen, Rep.?
Provide a succinct answer. -28.45. In the year 2005, what is the difference between the Gross intake ratio(%) in Caribbean small states and Gross intake ratio(%) in Least developed countries?
Provide a succinct answer. -26.62. In the year 2005, what is the difference between the Gross intake ratio(%) of Caribbean small states and Gross intake ratio(%) of Slovak Republic?
Offer a very short reply. -5.96. In the year 2005, what is the difference between the Gross intake ratio(%) in Caribbean small states and Gross intake ratio(%) in Yemen, Rep.?
Ensure brevity in your answer.  -34.24. In the year 2005, what is the difference between the Gross intake ratio(%) in Least developed countries and Gross intake ratio(%) in Slovak Republic?
Provide a short and direct response. 20.67. In the year 2005, what is the difference between the Gross intake ratio(%) in Least developed countries and Gross intake ratio(%) in Yemen, Rep.?
Offer a terse response. -7.61. In the year 2005, what is the difference between the Gross intake ratio(%) in Slovak Republic and Gross intake ratio(%) in Yemen, Rep.?
Your response must be concise. -28.28. In the year 2008, what is the difference between the Gross intake ratio(%) of Caribbean small states and Gross intake ratio(%) of Least developed countries?
Offer a very short reply. -36.02. In the year 2008, what is the difference between the Gross intake ratio(%) in Caribbean small states and Gross intake ratio(%) in Slovak Republic?
Offer a very short reply. -9.44. In the year 2008, what is the difference between the Gross intake ratio(%) of Caribbean small states and Gross intake ratio(%) of Yemen, Rep.?
Keep it short and to the point. -24.82. In the year 2008, what is the difference between the Gross intake ratio(%) in Least developed countries and Gross intake ratio(%) in Slovak Republic?
Keep it short and to the point. 26.58. In the year 2008, what is the difference between the Gross intake ratio(%) in Least developed countries and Gross intake ratio(%) in Yemen, Rep.?
Offer a very short reply. 11.2. In the year 2008, what is the difference between the Gross intake ratio(%) of Slovak Republic and Gross intake ratio(%) of Yemen, Rep.?
Offer a very short reply. -15.38. In the year 2010, what is the difference between the Gross intake ratio(%) in Caribbean small states and Gross intake ratio(%) in Least developed countries?
Your answer should be very brief. -33.85. In the year 2010, what is the difference between the Gross intake ratio(%) of Caribbean small states and Gross intake ratio(%) of Slovak Republic?
Your answer should be very brief. -5.01. In the year 2010, what is the difference between the Gross intake ratio(%) in Caribbean small states and Gross intake ratio(%) in Yemen, Rep.?
Your answer should be very brief. -25.96. In the year 2010, what is the difference between the Gross intake ratio(%) of Least developed countries and Gross intake ratio(%) of Slovak Republic?
Your answer should be very brief. 28.85. In the year 2010, what is the difference between the Gross intake ratio(%) of Least developed countries and Gross intake ratio(%) of Yemen, Rep.?
Your answer should be very brief. 7.89. In the year 2010, what is the difference between the Gross intake ratio(%) of Slovak Republic and Gross intake ratio(%) of Yemen, Rep.?
Give a very brief answer. -20.96. In the year 2012, what is the difference between the Gross intake ratio(%) of Caribbean small states and Gross intake ratio(%) of Least developed countries?
Provide a succinct answer. -40.83. In the year 2012, what is the difference between the Gross intake ratio(%) of Caribbean small states and Gross intake ratio(%) of Slovak Republic?
Ensure brevity in your answer.  -8.14. In the year 2012, what is the difference between the Gross intake ratio(%) of Caribbean small states and Gross intake ratio(%) of Yemen, Rep.?
Offer a terse response. -30.14. In the year 2012, what is the difference between the Gross intake ratio(%) in Least developed countries and Gross intake ratio(%) in Slovak Republic?
Offer a very short reply. 32.69. In the year 2012, what is the difference between the Gross intake ratio(%) in Least developed countries and Gross intake ratio(%) in Yemen, Rep.?
Offer a very short reply. 10.69. In the year 2012, what is the difference between the Gross intake ratio(%) of Slovak Republic and Gross intake ratio(%) of Yemen, Rep.?
Offer a terse response. -22. What is the ratio of the Gross intake ratio(%) of Caribbean small states in 2001 to that in 2002?
Keep it short and to the point. 1.03. What is the ratio of the Gross intake ratio(%) in Least developed countries in 2001 to that in 2002?
Keep it short and to the point. 0.95. What is the ratio of the Gross intake ratio(%) of Slovak Republic in 2001 to that in 2002?
Your answer should be very brief. 1.06. What is the ratio of the Gross intake ratio(%) of Yemen, Rep. in 2001 to that in 2002?
Your response must be concise. 0.94. What is the ratio of the Gross intake ratio(%) in Caribbean small states in 2001 to that in 2003?
Offer a very short reply. 1.06. What is the ratio of the Gross intake ratio(%) of Least developed countries in 2001 to that in 2003?
Give a very brief answer. 0.95. What is the ratio of the Gross intake ratio(%) in Slovak Republic in 2001 to that in 2003?
Ensure brevity in your answer.  1.03. What is the ratio of the Gross intake ratio(%) of Yemen, Rep. in 2001 to that in 2003?
Ensure brevity in your answer.  0.87. What is the ratio of the Gross intake ratio(%) of Caribbean small states in 2001 to that in 2004?
Offer a very short reply. 1.09. What is the ratio of the Gross intake ratio(%) in Least developed countries in 2001 to that in 2004?
Offer a terse response. 0.95. What is the ratio of the Gross intake ratio(%) in Slovak Republic in 2001 to that in 2004?
Your response must be concise. 1.02. What is the ratio of the Gross intake ratio(%) of Yemen, Rep. in 2001 to that in 2004?
Offer a very short reply. 0.83. What is the ratio of the Gross intake ratio(%) of Caribbean small states in 2001 to that in 2005?
Give a very brief answer. 1.1. What is the ratio of the Gross intake ratio(%) in Least developed countries in 2001 to that in 2005?
Your response must be concise. 0.93. What is the ratio of the Gross intake ratio(%) of Yemen, Rep. in 2001 to that in 2005?
Your response must be concise. 0.81. What is the ratio of the Gross intake ratio(%) of Caribbean small states in 2001 to that in 2008?
Your answer should be very brief. 1.13. What is the ratio of the Gross intake ratio(%) in Least developed countries in 2001 to that in 2008?
Offer a terse response. 0.87. What is the ratio of the Gross intake ratio(%) in Slovak Republic in 2001 to that in 2008?
Ensure brevity in your answer.  0.98. What is the ratio of the Gross intake ratio(%) of Yemen, Rep. in 2001 to that in 2008?
Your answer should be very brief. 0.9. What is the ratio of the Gross intake ratio(%) in Caribbean small states in 2001 to that in 2010?
Ensure brevity in your answer.  1.12. What is the ratio of the Gross intake ratio(%) of Least developed countries in 2001 to that in 2010?
Make the answer very short. 0.88. What is the ratio of the Gross intake ratio(%) in Slovak Republic in 2001 to that in 2010?
Provide a succinct answer. 1.02. What is the ratio of the Gross intake ratio(%) of Yemen, Rep. in 2001 to that in 2010?
Make the answer very short. 0.88. What is the ratio of the Gross intake ratio(%) of Caribbean small states in 2001 to that in 2012?
Offer a terse response. 1.13. What is the ratio of the Gross intake ratio(%) of Least developed countries in 2001 to that in 2012?
Offer a terse response. 0.84. What is the ratio of the Gross intake ratio(%) of Slovak Republic in 2001 to that in 2012?
Your answer should be compact. 1. What is the ratio of the Gross intake ratio(%) of Yemen, Rep. in 2001 to that in 2012?
Offer a terse response. 0.86. What is the ratio of the Gross intake ratio(%) in Caribbean small states in 2002 to that in 2003?
Keep it short and to the point. 1.03. What is the ratio of the Gross intake ratio(%) in Least developed countries in 2002 to that in 2003?
Your answer should be compact. 1. What is the ratio of the Gross intake ratio(%) in Slovak Republic in 2002 to that in 2003?
Keep it short and to the point. 0.98. What is the ratio of the Gross intake ratio(%) of Yemen, Rep. in 2002 to that in 2003?
Your answer should be compact. 0.93. What is the ratio of the Gross intake ratio(%) of Caribbean small states in 2002 to that in 2004?
Keep it short and to the point. 1.05. What is the ratio of the Gross intake ratio(%) in Least developed countries in 2002 to that in 2004?
Offer a very short reply. 0.99. What is the ratio of the Gross intake ratio(%) in Slovak Republic in 2002 to that in 2004?
Offer a terse response. 0.97. What is the ratio of the Gross intake ratio(%) in Yemen, Rep. in 2002 to that in 2004?
Ensure brevity in your answer.  0.88. What is the ratio of the Gross intake ratio(%) in Caribbean small states in 2002 to that in 2005?
Provide a succinct answer. 1.07. What is the ratio of the Gross intake ratio(%) of Least developed countries in 2002 to that in 2005?
Ensure brevity in your answer.  0.97. What is the ratio of the Gross intake ratio(%) of Slovak Republic in 2002 to that in 2005?
Make the answer very short. 0.94. What is the ratio of the Gross intake ratio(%) of Yemen, Rep. in 2002 to that in 2005?
Keep it short and to the point. 0.86. What is the ratio of the Gross intake ratio(%) in Caribbean small states in 2002 to that in 2008?
Ensure brevity in your answer.  1.09. What is the ratio of the Gross intake ratio(%) in Least developed countries in 2002 to that in 2008?
Give a very brief answer. 0.92. What is the ratio of the Gross intake ratio(%) in Slovak Republic in 2002 to that in 2008?
Offer a very short reply. 0.93. What is the ratio of the Gross intake ratio(%) in Yemen, Rep. in 2002 to that in 2008?
Provide a succinct answer. 0.95. What is the ratio of the Gross intake ratio(%) of Caribbean small states in 2002 to that in 2010?
Your response must be concise. 1.08. What is the ratio of the Gross intake ratio(%) in Least developed countries in 2002 to that in 2010?
Make the answer very short. 0.93. What is the ratio of the Gross intake ratio(%) in Slovak Republic in 2002 to that in 2010?
Ensure brevity in your answer.  0.96. What is the ratio of the Gross intake ratio(%) in Caribbean small states in 2002 to that in 2012?
Your response must be concise. 1.1. What is the ratio of the Gross intake ratio(%) of Least developed countries in 2002 to that in 2012?
Your response must be concise. 0.89. What is the ratio of the Gross intake ratio(%) of Slovak Republic in 2002 to that in 2012?
Ensure brevity in your answer.  0.94. What is the ratio of the Gross intake ratio(%) of Yemen, Rep. in 2002 to that in 2012?
Offer a very short reply. 0.91. What is the ratio of the Gross intake ratio(%) in Caribbean small states in 2003 to that in 2004?
Give a very brief answer. 1.02. What is the ratio of the Gross intake ratio(%) in Slovak Republic in 2003 to that in 2004?
Keep it short and to the point. 0.99. What is the ratio of the Gross intake ratio(%) in Yemen, Rep. in 2003 to that in 2004?
Ensure brevity in your answer.  0.95. What is the ratio of the Gross intake ratio(%) of Caribbean small states in 2003 to that in 2005?
Give a very brief answer. 1.04. What is the ratio of the Gross intake ratio(%) in Least developed countries in 2003 to that in 2005?
Make the answer very short. 0.97. What is the ratio of the Gross intake ratio(%) in Slovak Republic in 2003 to that in 2005?
Offer a terse response. 0.96. What is the ratio of the Gross intake ratio(%) in Caribbean small states in 2003 to that in 2008?
Your answer should be very brief. 1.07. What is the ratio of the Gross intake ratio(%) of Least developed countries in 2003 to that in 2008?
Make the answer very short. 0.92. What is the ratio of the Gross intake ratio(%) of Slovak Republic in 2003 to that in 2008?
Your answer should be compact. 0.95. What is the ratio of the Gross intake ratio(%) of Yemen, Rep. in 2003 to that in 2008?
Ensure brevity in your answer.  1.03. What is the ratio of the Gross intake ratio(%) of Caribbean small states in 2003 to that in 2010?
Offer a very short reply. 1.06. What is the ratio of the Gross intake ratio(%) in Slovak Republic in 2003 to that in 2010?
Provide a succinct answer. 0.98. What is the ratio of the Gross intake ratio(%) of Yemen, Rep. in 2003 to that in 2010?
Provide a succinct answer. 1.01. What is the ratio of the Gross intake ratio(%) of Caribbean small states in 2003 to that in 2012?
Your answer should be compact. 1.07. What is the ratio of the Gross intake ratio(%) of Least developed countries in 2003 to that in 2012?
Provide a succinct answer. 0.89. What is the ratio of the Gross intake ratio(%) of Slovak Republic in 2003 to that in 2012?
Offer a very short reply. 0.96. What is the ratio of the Gross intake ratio(%) of Yemen, Rep. in 2003 to that in 2012?
Keep it short and to the point. 0.98. What is the ratio of the Gross intake ratio(%) in Caribbean small states in 2004 to that in 2005?
Make the answer very short. 1.01. What is the ratio of the Gross intake ratio(%) in Least developed countries in 2004 to that in 2005?
Your answer should be very brief. 0.98. What is the ratio of the Gross intake ratio(%) of Slovak Republic in 2004 to that in 2005?
Provide a succinct answer. 0.97. What is the ratio of the Gross intake ratio(%) of Yemen, Rep. in 2004 to that in 2005?
Your response must be concise. 0.98. What is the ratio of the Gross intake ratio(%) of Caribbean small states in 2004 to that in 2008?
Offer a terse response. 1.04. What is the ratio of the Gross intake ratio(%) of Least developed countries in 2004 to that in 2008?
Your response must be concise. 0.92. What is the ratio of the Gross intake ratio(%) in Slovak Republic in 2004 to that in 2008?
Ensure brevity in your answer.  0.96. What is the ratio of the Gross intake ratio(%) of Yemen, Rep. in 2004 to that in 2008?
Offer a terse response. 1.08. What is the ratio of the Gross intake ratio(%) of Caribbean small states in 2004 to that in 2010?
Your response must be concise. 1.03. What is the ratio of the Gross intake ratio(%) of Least developed countries in 2004 to that in 2010?
Provide a succinct answer. 0.93. What is the ratio of the Gross intake ratio(%) of Slovak Republic in 2004 to that in 2010?
Provide a succinct answer. 1. What is the ratio of the Gross intake ratio(%) of Yemen, Rep. in 2004 to that in 2010?
Ensure brevity in your answer.  1.06. What is the ratio of the Gross intake ratio(%) in Caribbean small states in 2004 to that in 2012?
Your answer should be compact. 1.04. What is the ratio of the Gross intake ratio(%) of Least developed countries in 2004 to that in 2012?
Offer a very short reply. 0.89. What is the ratio of the Gross intake ratio(%) of Yemen, Rep. in 2004 to that in 2012?
Your response must be concise. 1.03. What is the ratio of the Gross intake ratio(%) in Caribbean small states in 2005 to that in 2008?
Make the answer very short. 1.03. What is the ratio of the Gross intake ratio(%) of Least developed countries in 2005 to that in 2008?
Make the answer very short. 0.95. What is the ratio of the Gross intake ratio(%) of Slovak Republic in 2005 to that in 2008?
Ensure brevity in your answer.  0.99. What is the ratio of the Gross intake ratio(%) in Yemen, Rep. in 2005 to that in 2008?
Give a very brief answer. 1.1. What is the ratio of the Gross intake ratio(%) in Caribbean small states in 2005 to that in 2010?
Ensure brevity in your answer.  1.02. What is the ratio of the Gross intake ratio(%) of Least developed countries in 2005 to that in 2010?
Your answer should be compact. 0.96. What is the ratio of the Gross intake ratio(%) of Slovak Republic in 2005 to that in 2010?
Give a very brief answer. 1.03. What is the ratio of the Gross intake ratio(%) in Yemen, Rep. in 2005 to that in 2010?
Provide a short and direct response. 1.08. What is the ratio of the Gross intake ratio(%) in Caribbean small states in 2005 to that in 2012?
Give a very brief answer. 1.03. What is the ratio of the Gross intake ratio(%) in Least developed countries in 2005 to that in 2012?
Provide a short and direct response. 0.91. What is the ratio of the Gross intake ratio(%) of Slovak Republic in 2005 to that in 2012?
Your response must be concise. 1. What is the ratio of the Gross intake ratio(%) of Yemen, Rep. in 2005 to that in 2012?
Provide a succinct answer. 1.06. What is the ratio of the Gross intake ratio(%) of Least developed countries in 2008 to that in 2010?
Offer a terse response. 1.01. What is the ratio of the Gross intake ratio(%) of Slovak Republic in 2008 to that in 2010?
Make the answer very short. 1.04. What is the ratio of the Gross intake ratio(%) of Yemen, Rep. in 2008 to that in 2010?
Give a very brief answer. 0.98. What is the ratio of the Gross intake ratio(%) of Caribbean small states in 2008 to that in 2012?
Provide a succinct answer. 1. What is the ratio of the Gross intake ratio(%) of Least developed countries in 2008 to that in 2012?
Keep it short and to the point. 0.96. What is the ratio of the Gross intake ratio(%) in Yemen, Rep. in 2008 to that in 2012?
Ensure brevity in your answer.  0.96. What is the ratio of the Gross intake ratio(%) of Caribbean small states in 2010 to that in 2012?
Make the answer very short. 1.01. What is the ratio of the Gross intake ratio(%) in Least developed countries in 2010 to that in 2012?
Your answer should be compact. 0.95. What is the ratio of the Gross intake ratio(%) in Slovak Republic in 2010 to that in 2012?
Keep it short and to the point. 0.98. What is the ratio of the Gross intake ratio(%) in Yemen, Rep. in 2010 to that in 2012?
Ensure brevity in your answer.  0.97. What is the difference between the highest and the second highest Gross intake ratio(%) in Caribbean small states?
Your answer should be compact. 3.31. What is the difference between the highest and the second highest Gross intake ratio(%) in Least developed countries?
Your response must be concise. 4.62. What is the difference between the highest and the second highest Gross intake ratio(%) in Slovak Republic?
Your response must be concise. 1.06. What is the difference between the highest and the second highest Gross intake ratio(%) in Yemen, Rep.?
Provide a succinct answer. 2.84. What is the difference between the highest and the lowest Gross intake ratio(%) in Caribbean small states?
Ensure brevity in your answer.  12.11. What is the difference between the highest and the lowest Gross intake ratio(%) in Least developed countries?
Your response must be concise. 20.63. What is the difference between the highest and the lowest Gross intake ratio(%) in Slovak Republic?
Ensure brevity in your answer.  7.21. What is the difference between the highest and the lowest Gross intake ratio(%) of Yemen, Rep.?
Your answer should be very brief. 23.89. 